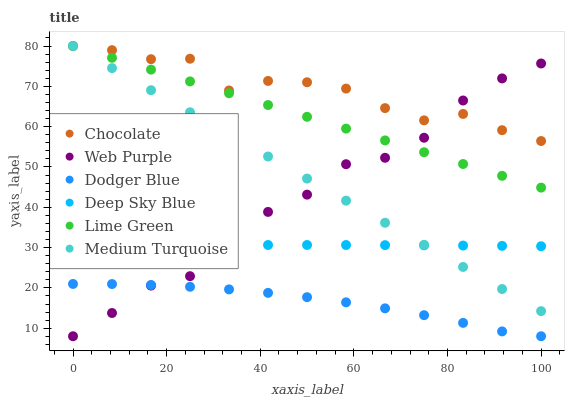Does Dodger Blue have the minimum area under the curve?
Answer yes or no. Yes. Does Chocolate have the maximum area under the curve?
Answer yes or no. Yes. Does Web Purple have the minimum area under the curve?
Answer yes or no. No. Does Web Purple have the maximum area under the curve?
Answer yes or no. No. Is Medium Turquoise the smoothest?
Answer yes or no. Yes. Is Web Purple the roughest?
Answer yes or no. Yes. Is Chocolate the smoothest?
Answer yes or no. No. Is Chocolate the roughest?
Answer yes or no. No. Does Web Purple have the lowest value?
Answer yes or no. Yes. Does Chocolate have the lowest value?
Answer yes or no. No. Does Lime Green have the highest value?
Answer yes or no. Yes. Does Web Purple have the highest value?
Answer yes or no. No. Is Dodger Blue less than Deep Sky Blue?
Answer yes or no. Yes. Is Chocolate greater than Dodger Blue?
Answer yes or no. Yes. Does Web Purple intersect Lime Green?
Answer yes or no. Yes. Is Web Purple less than Lime Green?
Answer yes or no. No. Is Web Purple greater than Lime Green?
Answer yes or no. No. Does Dodger Blue intersect Deep Sky Blue?
Answer yes or no. No. 